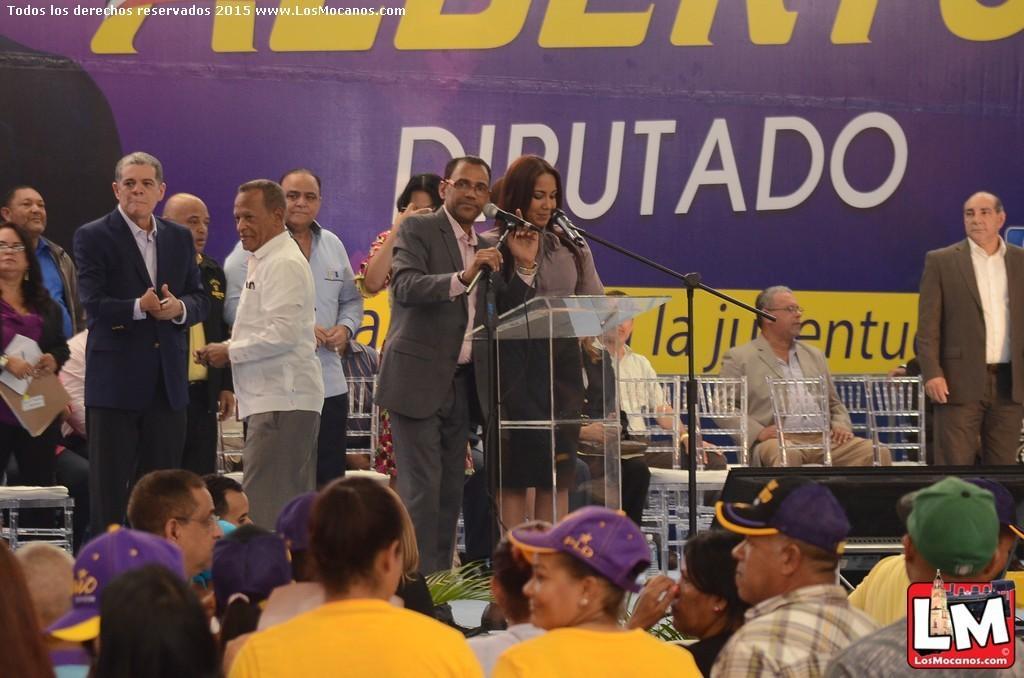Please provide a concise description of this image. In the bottom right, there is watermark and there are persons. In the background, there are persons standing on the stage on which, there are chairs arranged, there are persons sitting, mics attached to the stands, there is a stand and there is a hoarding. 